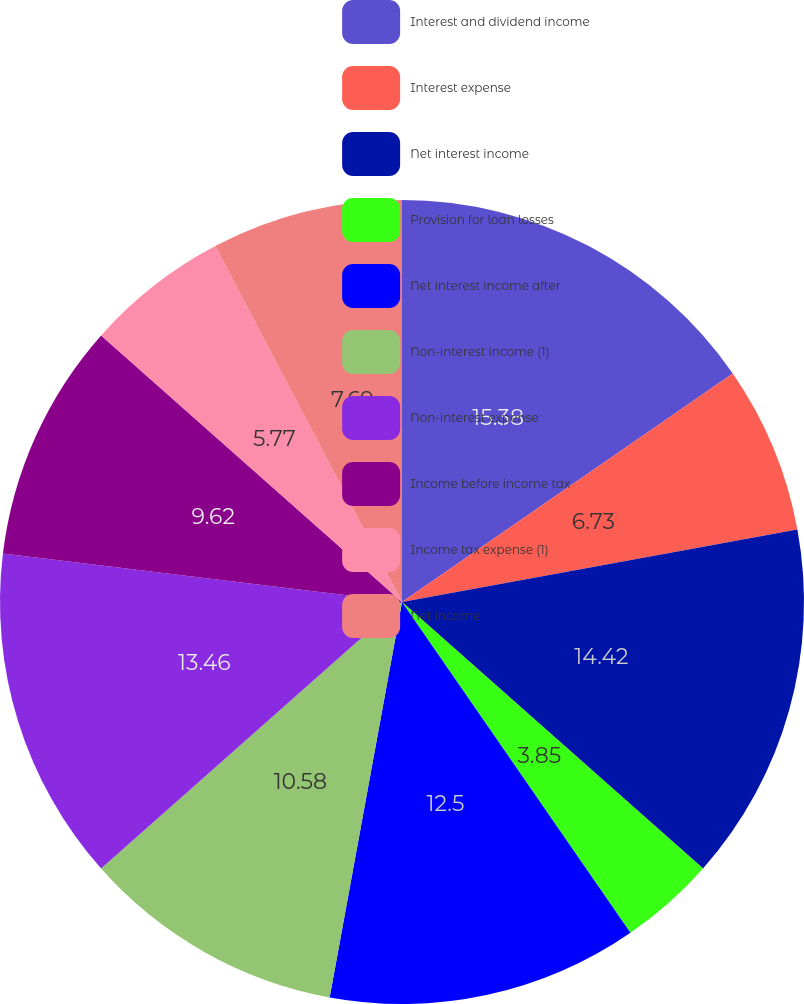Convert chart. <chart><loc_0><loc_0><loc_500><loc_500><pie_chart><fcel>Interest and dividend income<fcel>Interest expense<fcel>Net interest income<fcel>Provision for loan losses<fcel>Net interest income after<fcel>Non-interest income (1)<fcel>Non-interest expense<fcel>Income before income tax<fcel>Income tax expense (1)<fcel>Net income<nl><fcel>15.38%<fcel>6.73%<fcel>14.42%<fcel>3.85%<fcel>12.5%<fcel>10.58%<fcel>13.46%<fcel>9.62%<fcel>5.77%<fcel>7.69%<nl></chart> 